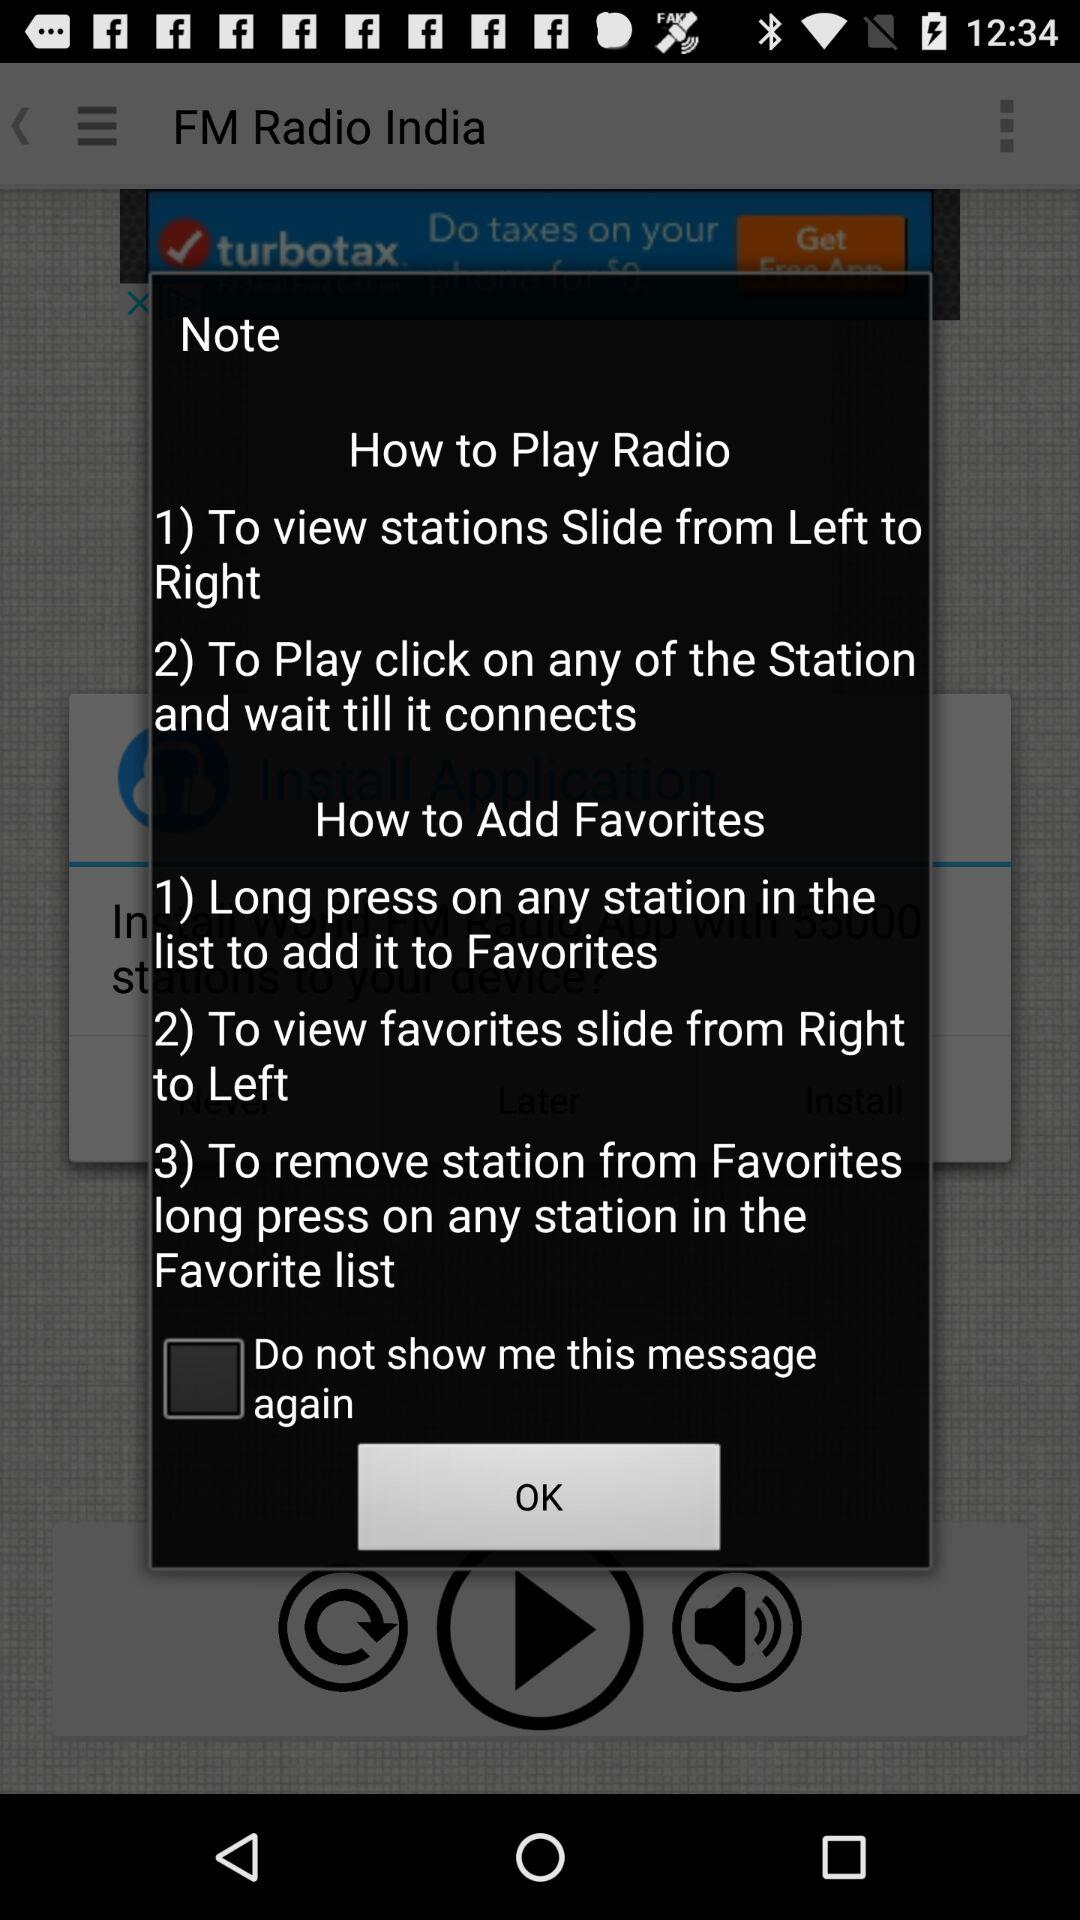What is the status of "Do not show me this message again"? The status is "off". 